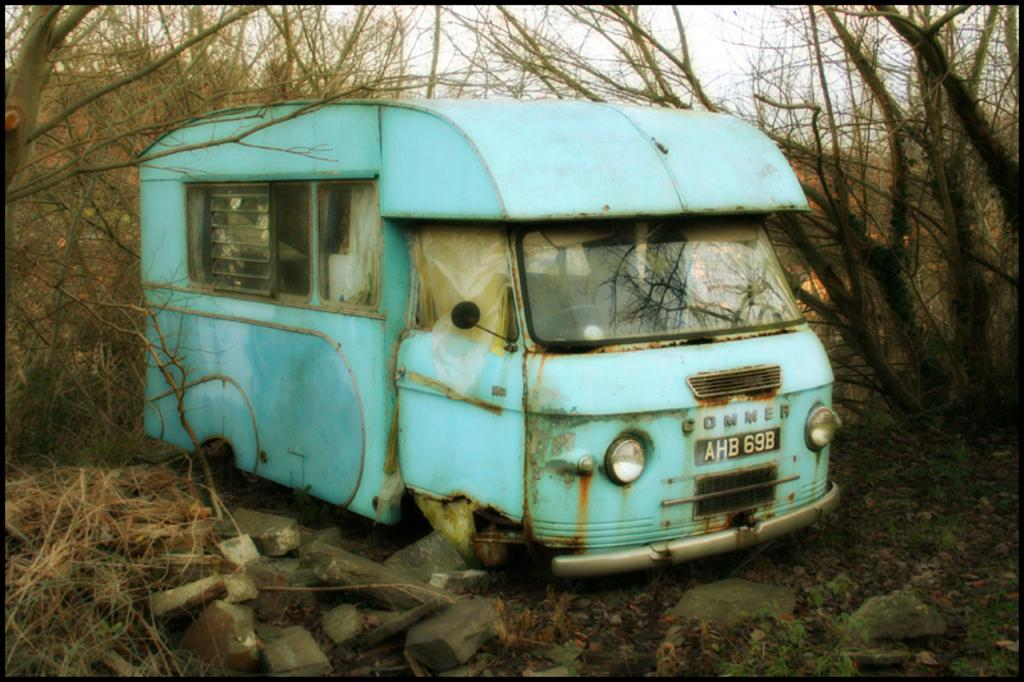What is located on the ground in the image? There is a vehicle on the ground in the image. What type of natural environment is visible in the image? Grass and trees are present in the image, indicating a natural environment. What other objects can be seen in the image? Stones are visible in the image. What is visible in the background of the image? Trees and the sky are visible in the background of the image. How is the image presented? The image appears to be in a photo frame. Can you see the parent holding the child's hands in the image? There is no reference to a parent or child holding hands in the image; it features a vehicle on the ground, grass, stones, trees, sky, and a photo frame. 